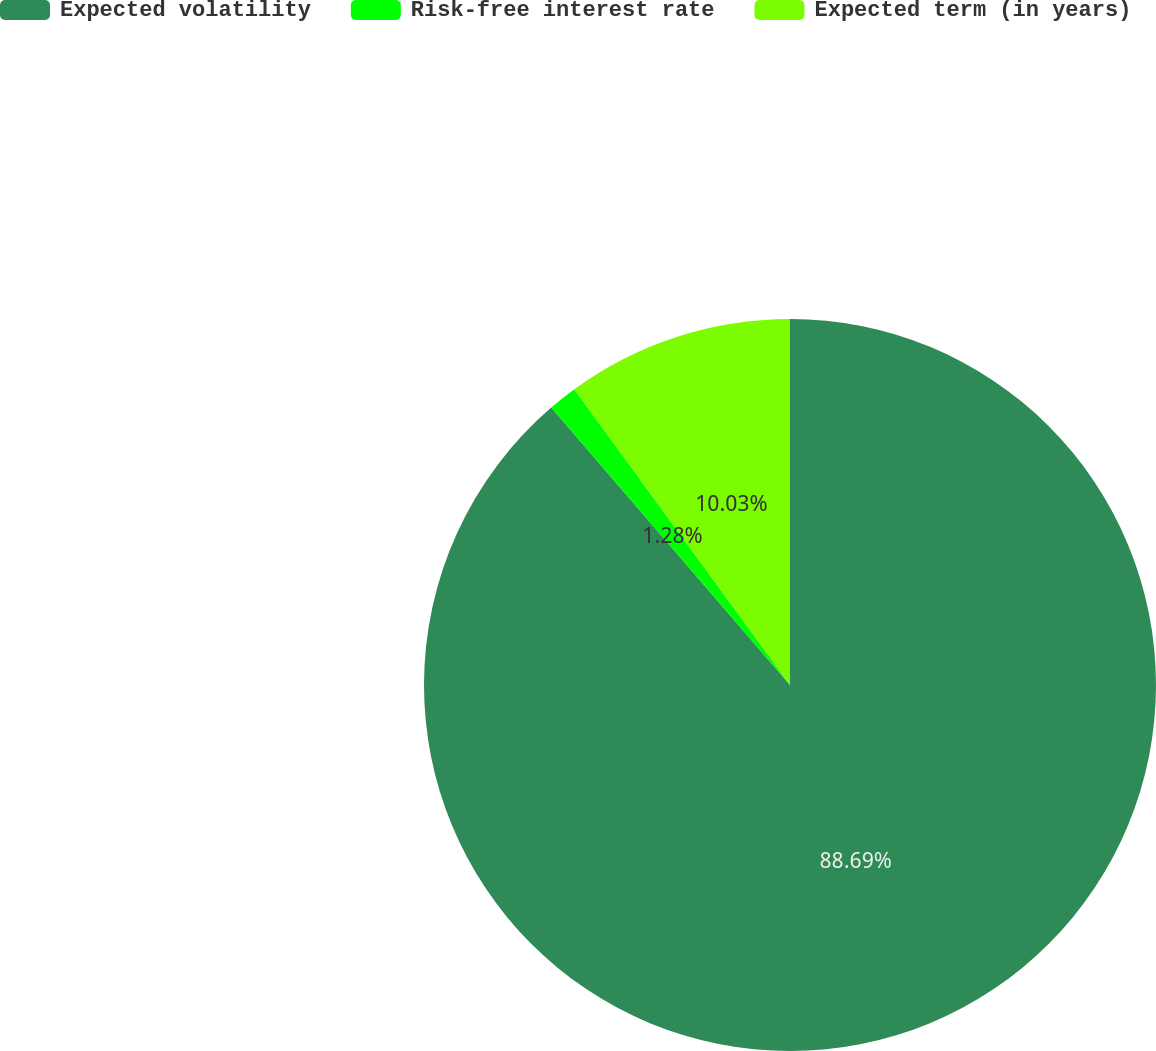<chart> <loc_0><loc_0><loc_500><loc_500><pie_chart><fcel>Expected volatility<fcel>Risk-free interest rate<fcel>Expected term (in years)<nl><fcel>88.69%<fcel>1.28%<fcel>10.03%<nl></chart> 